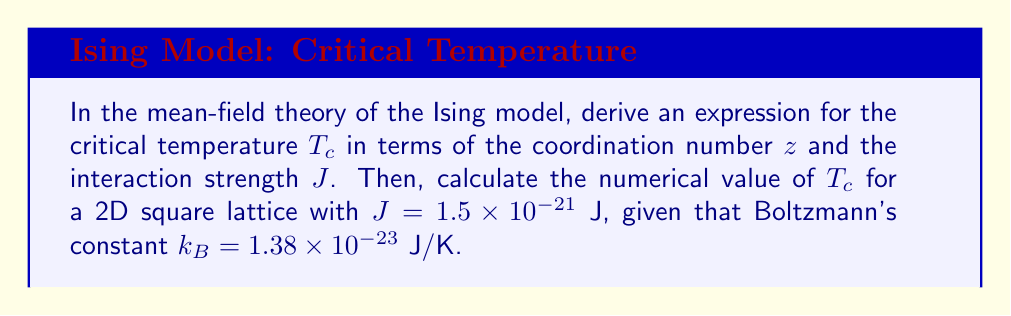Teach me how to tackle this problem. Let's approach this step-by-step:

1) In mean-field theory, we approximate the interaction of a spin with its neighbors by an average field. The mean-field Hamiltonian for a single spin is:

   $$H = -J z m \sigma - h \sigma$$

   where $m$ is the average magnetization, $z$ is the coordination number, and $h$ is the external field.

2) The self-consistent equation for magnetization is:

   $$m = \tanh(\beta J z m + \beta h)$$

   where $\beta = \frac{1}{k_B T}$.

3) At the critical temperature and zero external field $(h = 0)$, the magnetization vanishes $(m = 0)$. Expanding the tanh function for small $m$:

   $$m \approx (\beta J z) m - \frac{1}{3}(\beta J z)^3 m^3 + ...$$

4) For this to have a non-trivial solution, we must have:

   $$\beta_c J z = 1$$

5) Substituting $\beta_c = \frac{1}{k_B T_c}$, we get:

   $$T_c = \frac{J z}{k_B}$$

6) For a 2D square lattice, $z = 4$. Substituting the given values:

   $$T_c = \frac{(1.5 \times 10^{-21} \text{ J})(4)}{1.38 \times 10^{-23} \text{ J/K}}$$

7) Calculating:

   $$T_c = 434.78 \text{ K}$$
Answer: $T_c = \frac{J z}{k_B} = 434.78 \text{ K}$ 